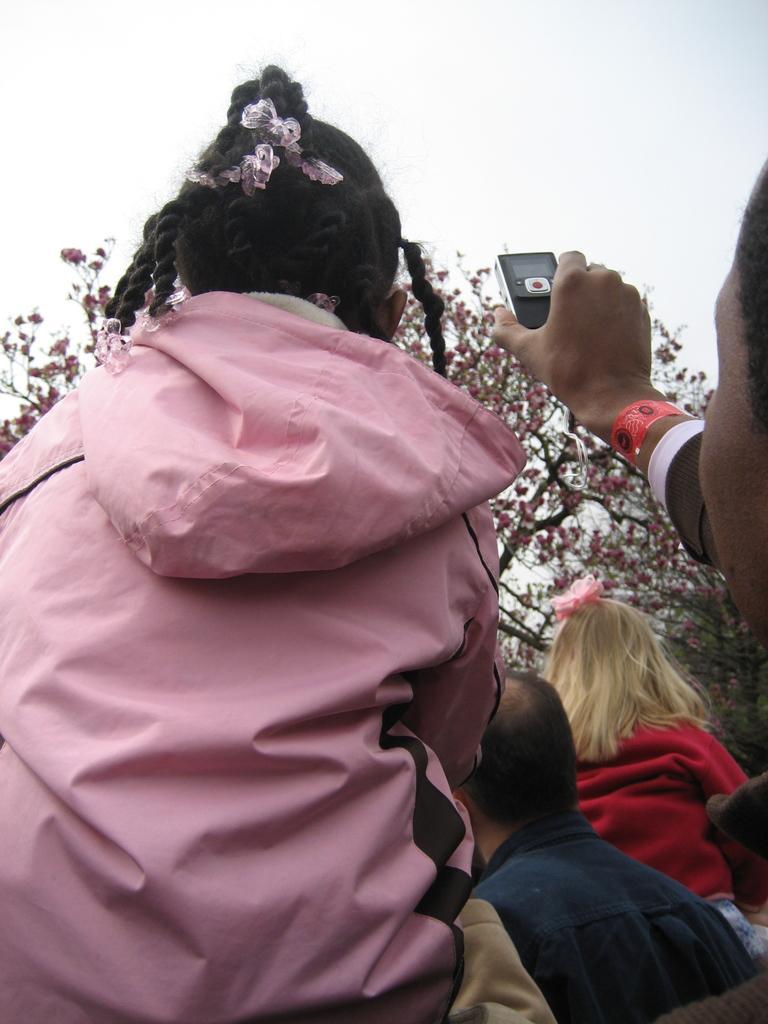How would you summarize this image in a sentence or two? In this picture there are people and we can see a gadget hold with hand. In the background of the image we can see trees and sky. 